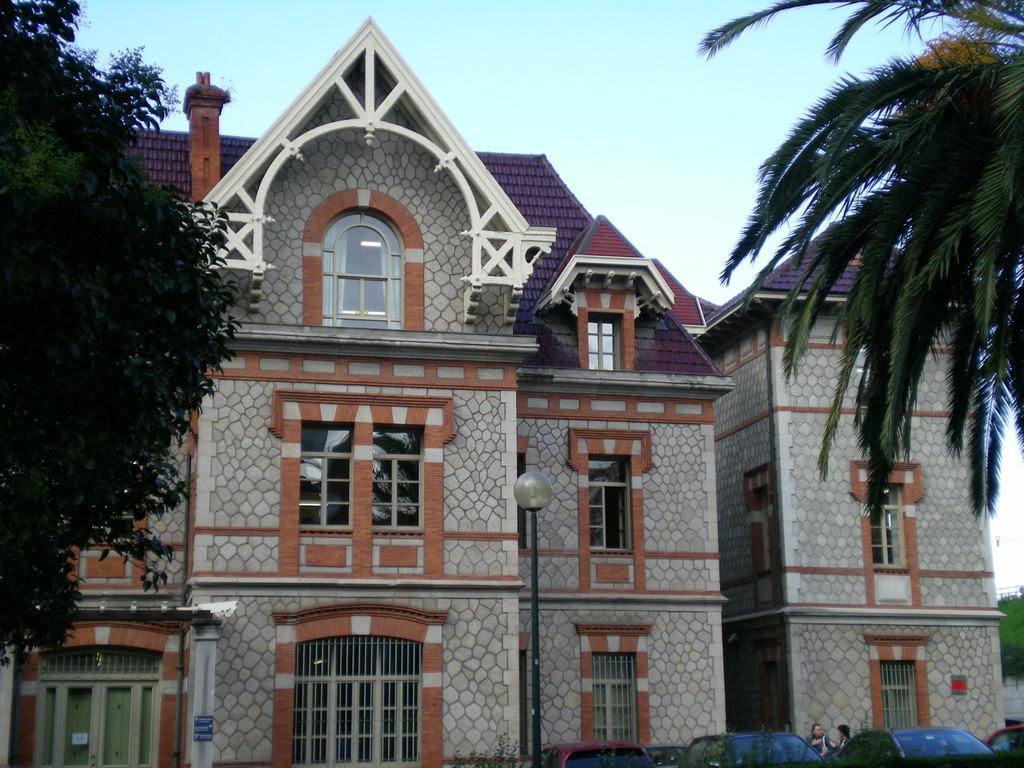In one or two sentences, can you explain what this image depicts? In this picture there are houses in the center of the image and there are trees on the right and left side of the image, there are cars at the bottom side of the image. 